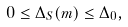Convert formula to latex. <formula><loc_0><loc_0><loc_500><loc_500>0 \leq \Delta _ { S } ( m ) \leq \Delta _ { 0 } ,</formula> 